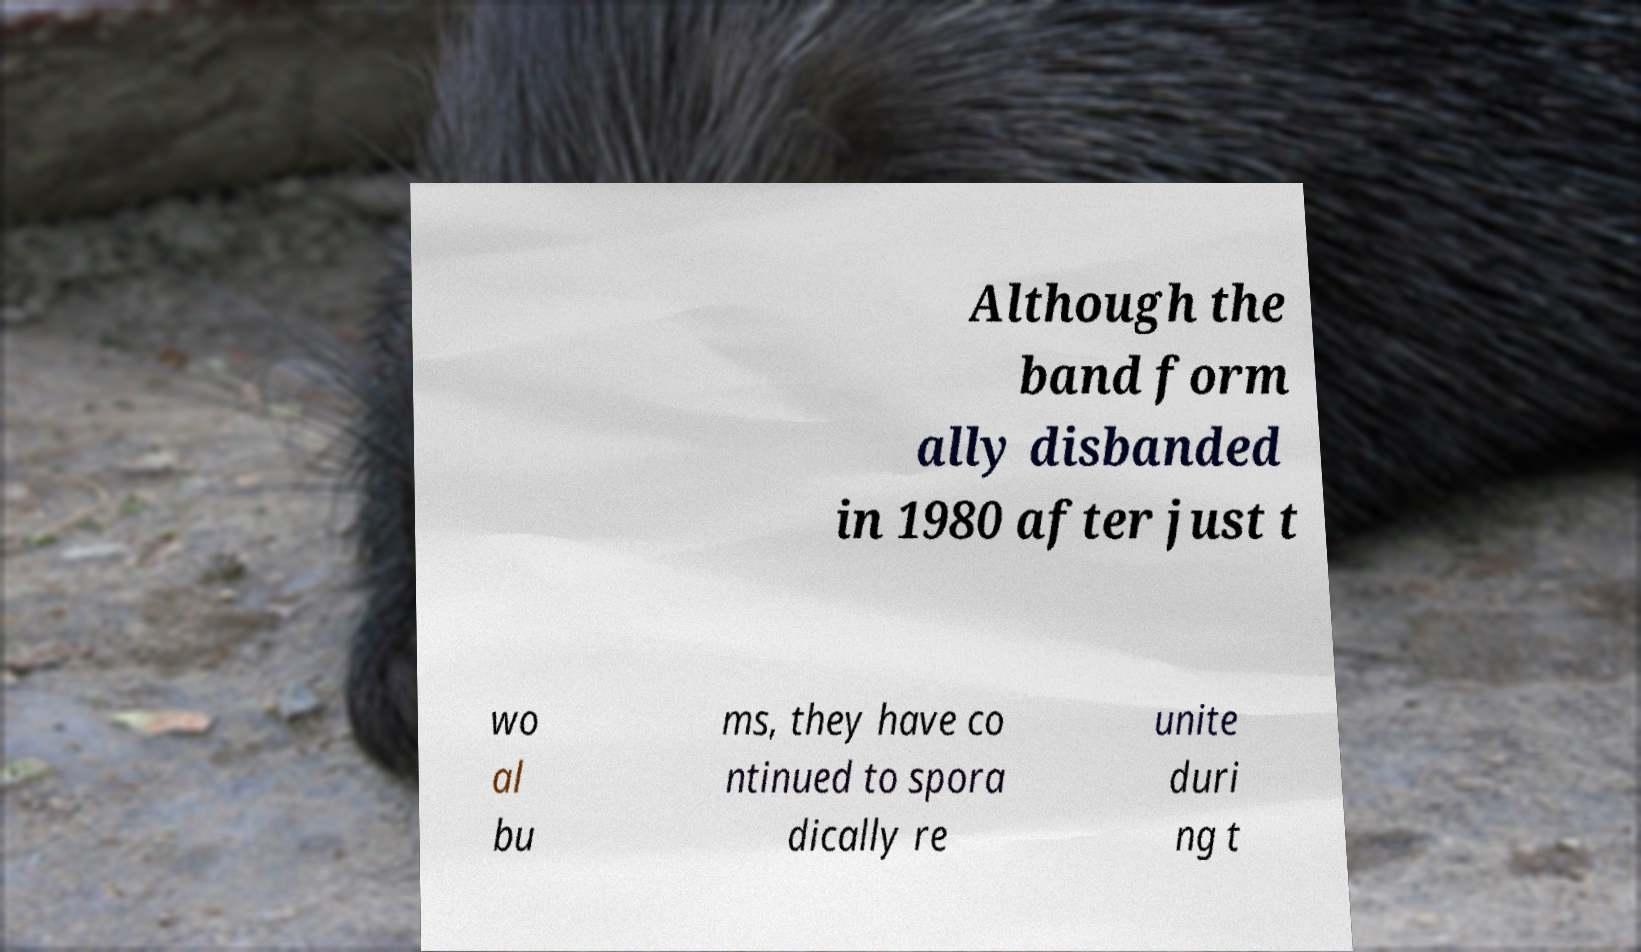Please read and relay the text visible in this image. What does it say? Although the band form ally disbanded in 1980 after just t wo al bu ms, they have co ntinued to spora dically re unite duri ng t 